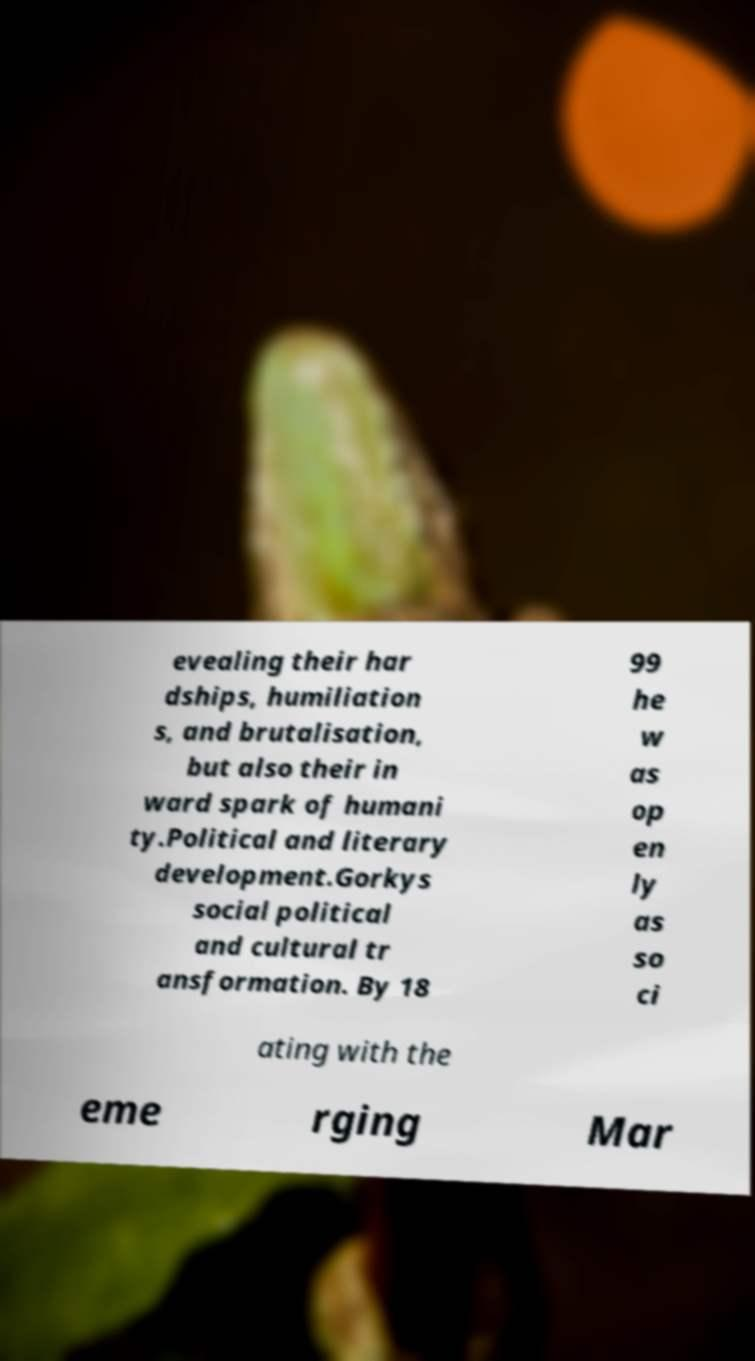Please read and relay the text visible in this image. What does it say? evealing their har dships, humiliation s, and brutalisation, but also their in ward spark of humani ty.Political and literary development.Gorkys social political and cultural tr ansformation. By 18 99 he w as op en ly as so ci ating with the eme rging Mar 